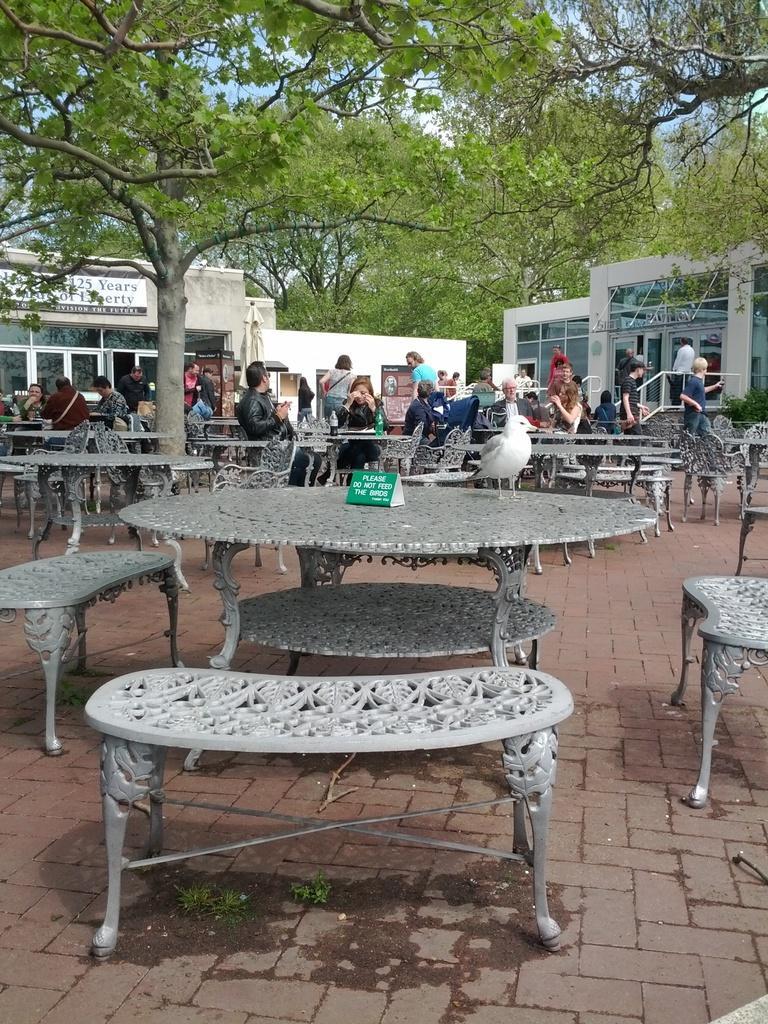Describe this image in one or two sentences. In this picture we can see some persons are sitting on the benches. This is table. On the background we can see some buildings and these are the trees. 